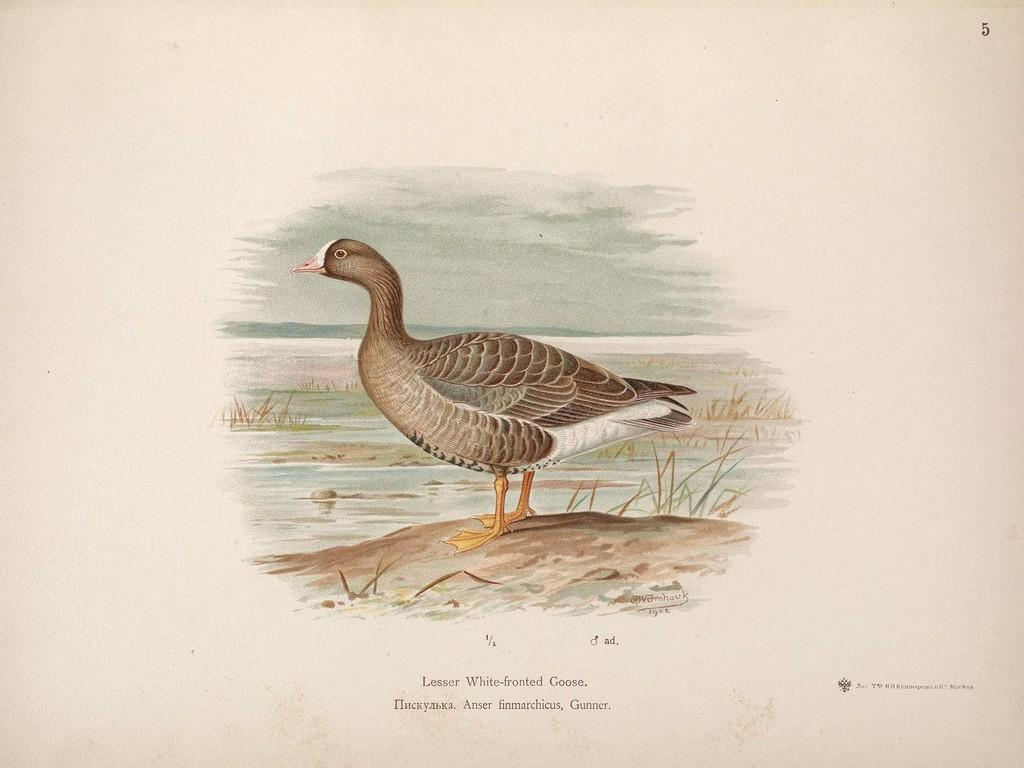What type of animal is in the image? There is a bird in the image. Can you describe the colors of the bird? The bird has brown, cream, and white colors. What can be seen in the background of the image? There is grass visible in the background of the image. Is there any text or writing on the image? Yes, there is text or writing on the image. How does the bird use its finger to perform magic in the image? There is no mention of a finger or magic in the image; it simply features a bird with specific colors and a grassy background. 